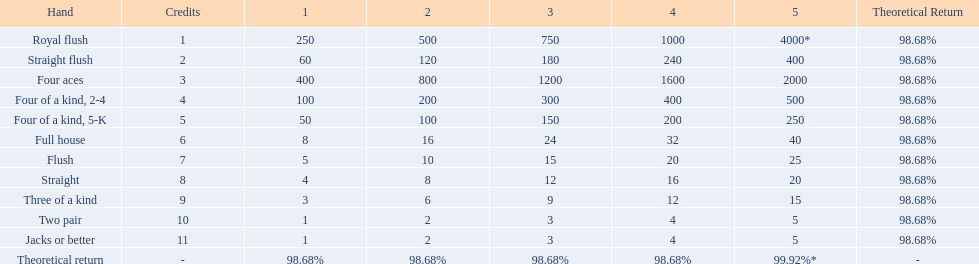What are each of the hands? Royal flush, Straight flush, Four aces, Four of a kind, 2-4, Four of a kind, 5-K, Full house, Flush, Straight, Three of a kind, Two pair, Jacks or better, Theoretical return. Which hand ranks higher between straights and flushes? Flush. 